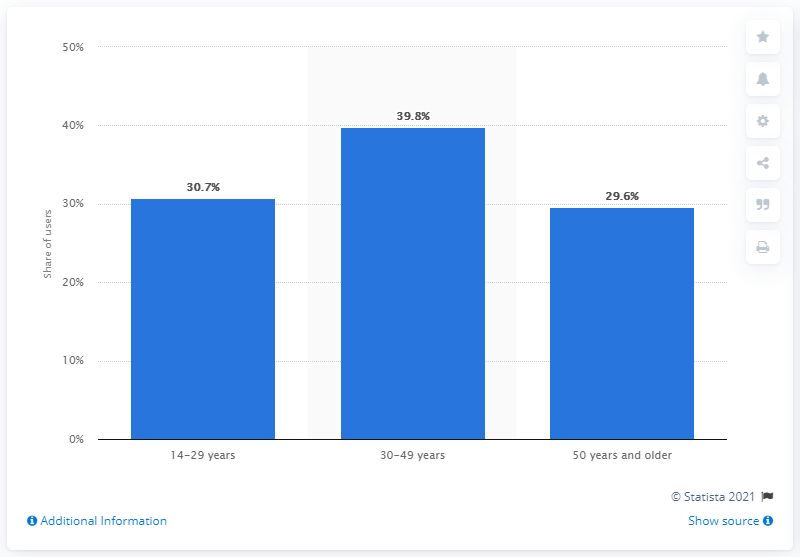Identify some key points in this picture. A study found that approximately 30.7% of mobile internet users were between the ages of 14 and 29. 